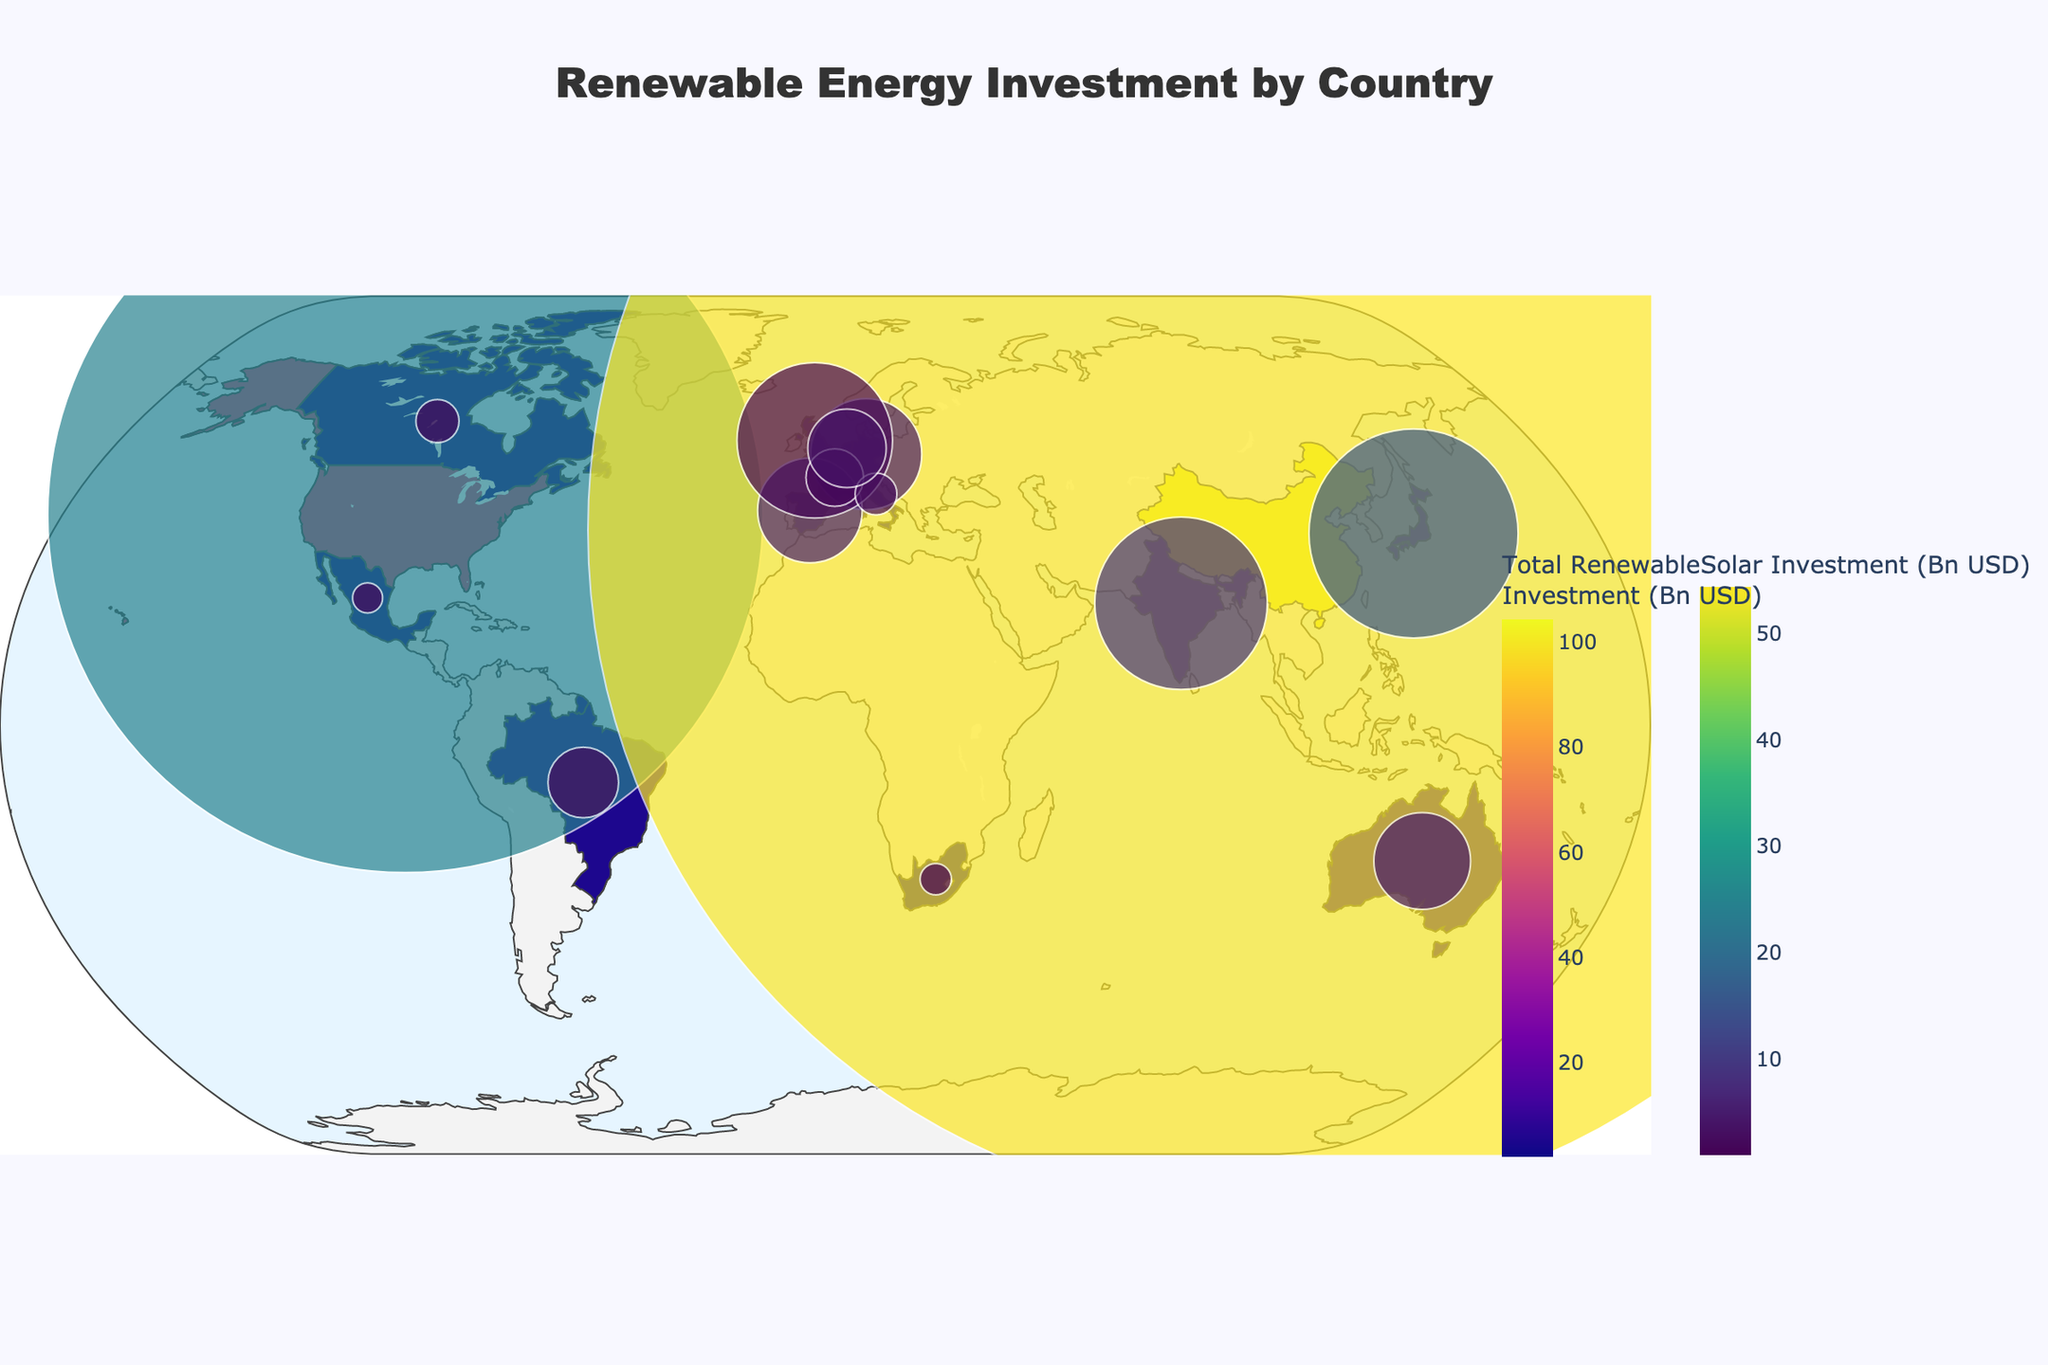What is the title of the plot? The title of the plot is displayed at the top center of the figure. It reads 'Renewable Energy Investment by Country'.
Answer: Renewable Energy Investment by Country Which country has the highest total renewable investment? By observing the color intensity on the choropleth map and the hover text for each country, China has the highest total renewable investment.
Answer: China What is the approximate solar investment for the United States? Hovering over the United States on the map displays the solar investment value. It shows an investment of $24.5 billion.
Answer: $24.5 billion How does the solar investment in Japan compare to the wind investment in Germany? Hovering over Japan shows a solar investment of $15.2 billion, and hovering over Germany shows a wind investment of $3.7 billion. Japan's solar investment is significantly higher.
Answer: Japan's solar investment is higher Which country has a larger wind investment, the United Kingdom or France? Hovering over the United Kingdom shows a wind investment of $10.4 billion, while France has a wind investment of $2.6 billion. The United Kingdom's wind investment is larger.
Answer: United Kingdom What is the sum of solar and wind investment in India? Hovering over India shows solar investment of $9.3 billion and wind investment of $3.9 billion. Summing these values gives $9.3B + $3.9B = $13.2 billion.
Answer: $13.2 billion In which country does solar investment count for a larger proportion of total renewable investment, Brazil or Mexico? For Brazil, the solar investment is $1.9 billion, and the total investment is $5.4 billion. The proportion is 1.9/5.4. For Mexico, solar investment is $1.7 billion out of a total of $2.3 billion, making the proportion 1.7/2.3. Comparing the two proportions shows that Mexico has a higher proportion of solar investment.
Answer: Mexico What is the total renewable investment for Australia, and how does it compare to Canada? Hovering over Australia shows a total renewable investment of $7.4 billion, while Canada has an investment of $3.3 billion. Australia’s total renewable investment is higher.
Answer: Australia is higher Which country has the smallest total renewable investment? By observing the color intensity on the map and the hover text, South Africa has the smallest total renewable investment, amounting to $2.4 billion.
Answer: South Africa 